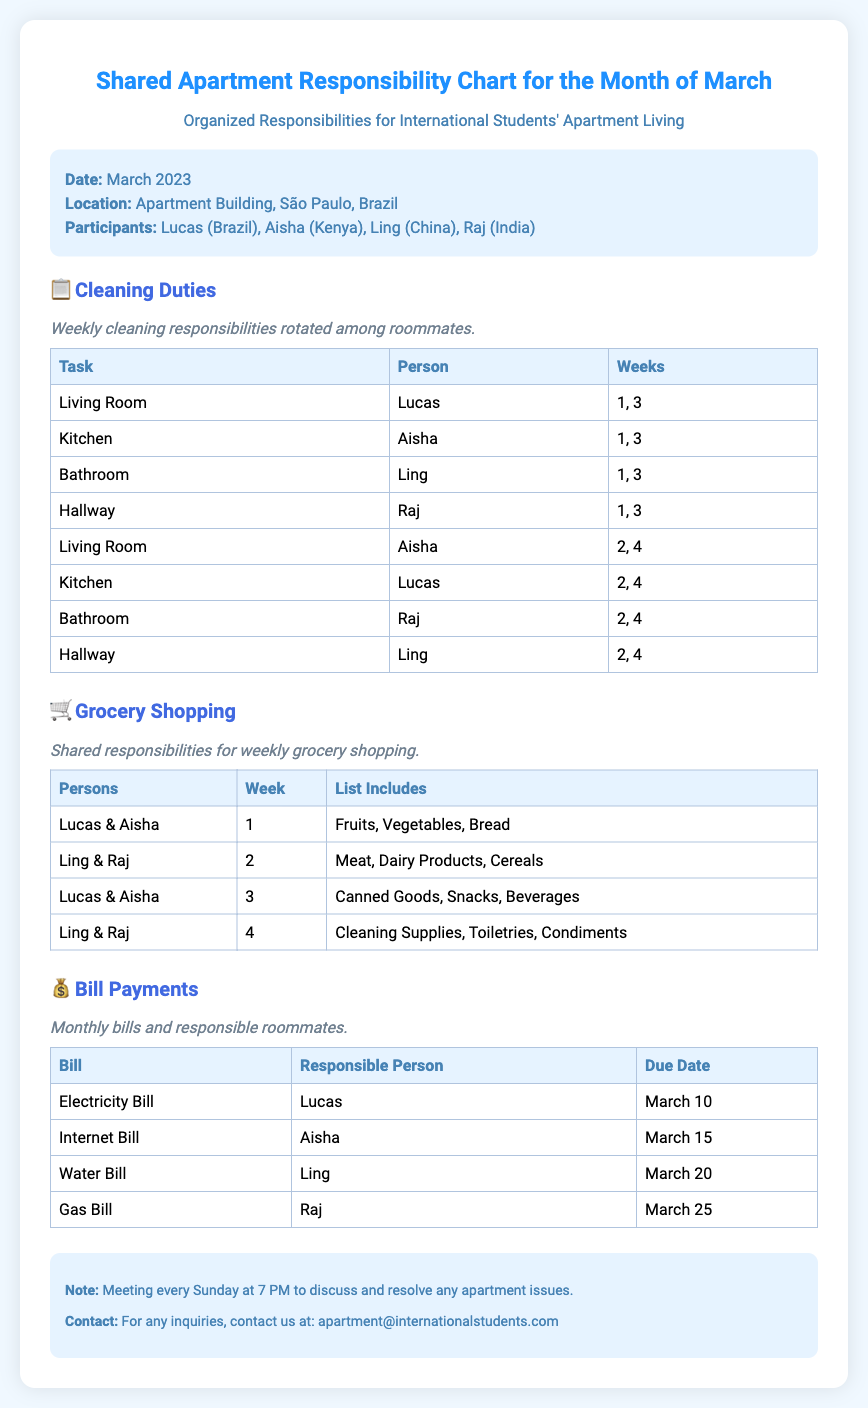What are the names of the participants? The participants listed in the document are Lucas, Aisha, Ling, and Raj.
Answer: Lucas, Aisha, Ling, Raj What is the due date for the electricity bill? The document states that the electricity bill is due on March 10.
Answer: March 10 Who is responsible for cleaning the bathroom in weeks 2 and 4? The document indicates that Raj is responsible for the bathroom during those weeks.
Answer: Raj Which items are included in the grocery list for week 1? The document specifies that the grocery list for week 1 includes Fruits, Vegetables, Bread.
Answer: Fruits, Vegetables, Bread How many times does Lucas clean the living room? According to the document, Lucas cleans the living room twice, in weeks 1 and 3.
Answer: 2 times What is the primary focus of this chart? The chart is designed to visually break down shared responsibilities among roommates for chores, shopping, and bills.
Answer: Shared responsibilities Who is responsible for the internet bill? The document states that Aisha is responsible for the internet bill.
Answer: Aisha On which day and time is the weekly meeting scheduled? The document indicates that the meeting is scheduled every Sunday at 7 PM.
Answer: Sunday at 7 PM What type of document is this? This document is a shared responsibility chart specifically for roommates living together.
Answer: Shared responsibility chart 